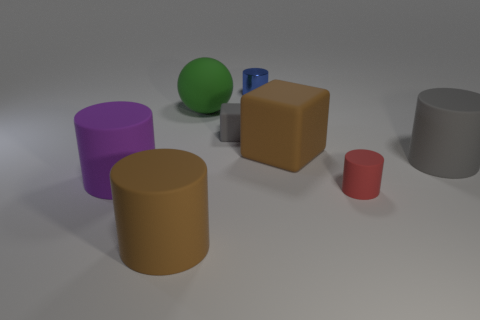How many big rubber cylinders have the same color as the tiny block?
Keep it short and to the point. 1. The big cylinder in front of the matte cylinder that is on the left side of the large brown matte thing that is left of the large green thing is made of what material?
Your response must be concise. Rubber. Is there any other thing that has the same shape as the purple matte object?
Your answer should be very brief. Yes. There is another tiny thing that is the same shape as the small blue thing; what color is it?
Offer a very short reply. Red. Is the color of the small cylinder that is in front of the green sphere the same as the big rubber object that is on the right side of the red object?
Provide a succinct answer. No. Is the number of large purple rubber objects in front of the large gray rubber object greater than the number of red cylinders?
Offer a terse response. No. What number of other things are there of the same size as the green ball?
Give a very brief answer. 4. What number of things are both behind the purple matte object and on the left side of the large gray cylinder?
Offer a terse response. 4. Is the big object that is in front of the red rubber cylinder made of the same material as the sphere?
Your answer should be compact. Yes. What shape is the brown thing that is behind the purple rubber object in front of the gray rubber thing that is in front of the small gray matte block?
Make the answer very short. Cube. 